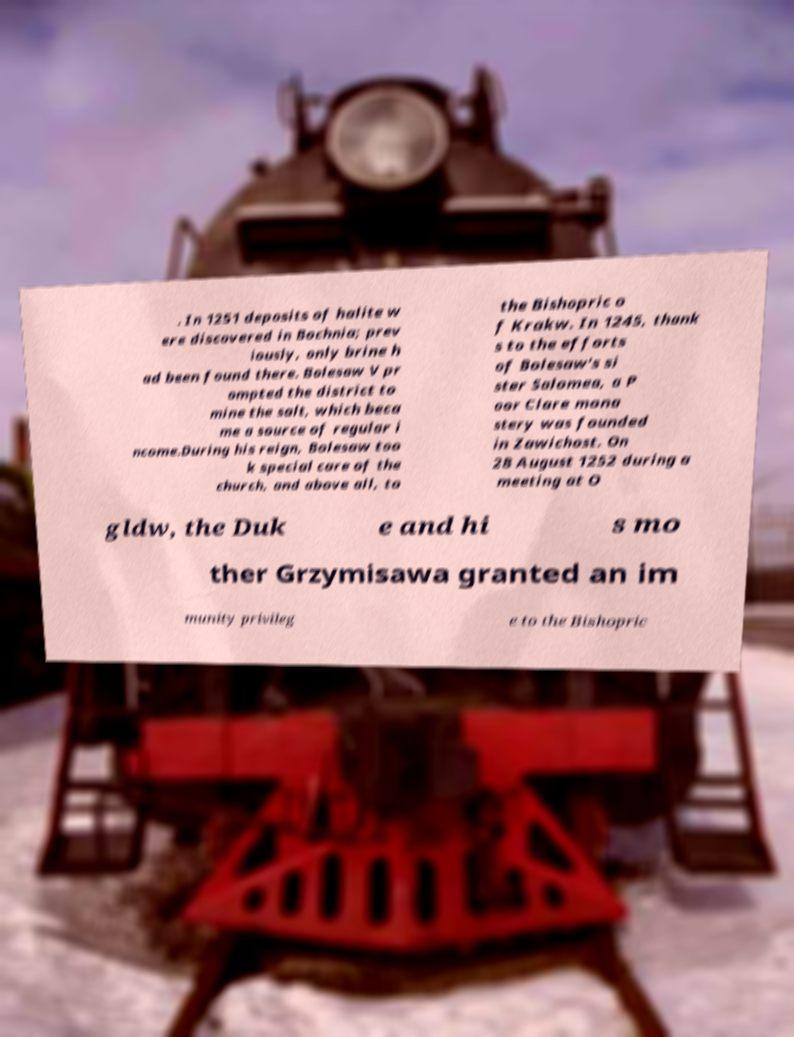I need the written content from this picture converted into text. Can you do that? . In 1251 deposits of halite w ere discovered in Bochnia; prev iously, only brine h ad been found there. Bolesaw V pr ompted the district to mine the salt, which beca me a source of regular i ncome.During his reign, Bolesaw too k special care of the church, and above all, to the Bishopric o f Krakw. In 1245, thank s to the efforts of Bolesaw's si ster Salomea, a P oor Clare mona stery was founded in Zawichost. On 28 August 1252 during a meeting at O gldw, the Duk e and hi s mo ther Grzymisawa granted an im munity privileg e to the Bishopric 